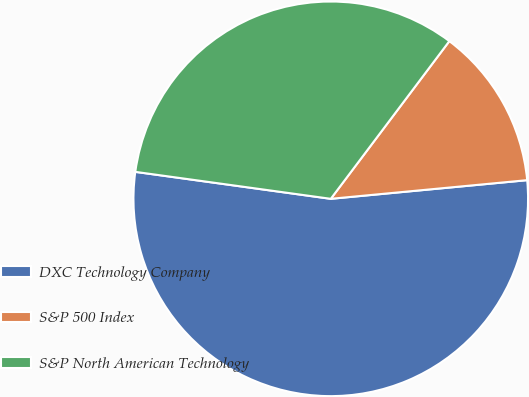Convert chart. <chart><loc_0><loc_0><loc_500><loc_500><pie_chart><fcel>DXC Technology Company<fcel>S&P 500 Index<fcel>S&P North American Technology<nl><fcel>53.69%<fcel>13.23%<fcel>33.08%<nl></chart> 